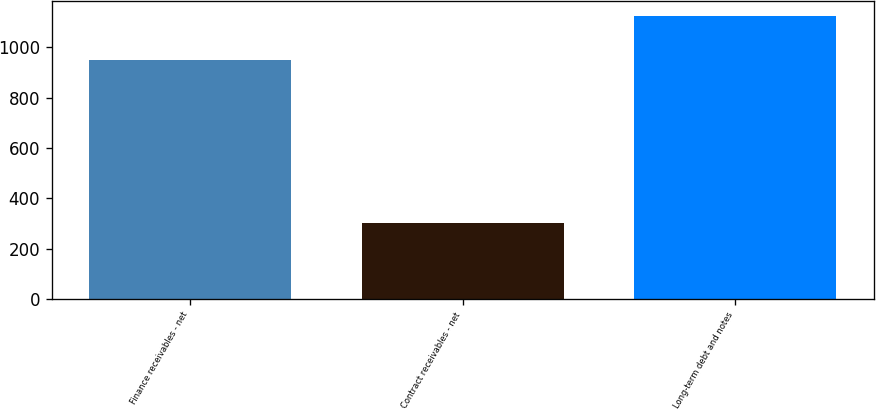Convert chart. <chart><loc_0><loc_0><loc_500><loc_500><bar_chart><fcel>Finance receivables - net<fcel>Contract receivables - net<fcel>Long-term debt and notes<nl><fcel>948.9<fcel>300.6<fcel>1126.7<nl></chart> 